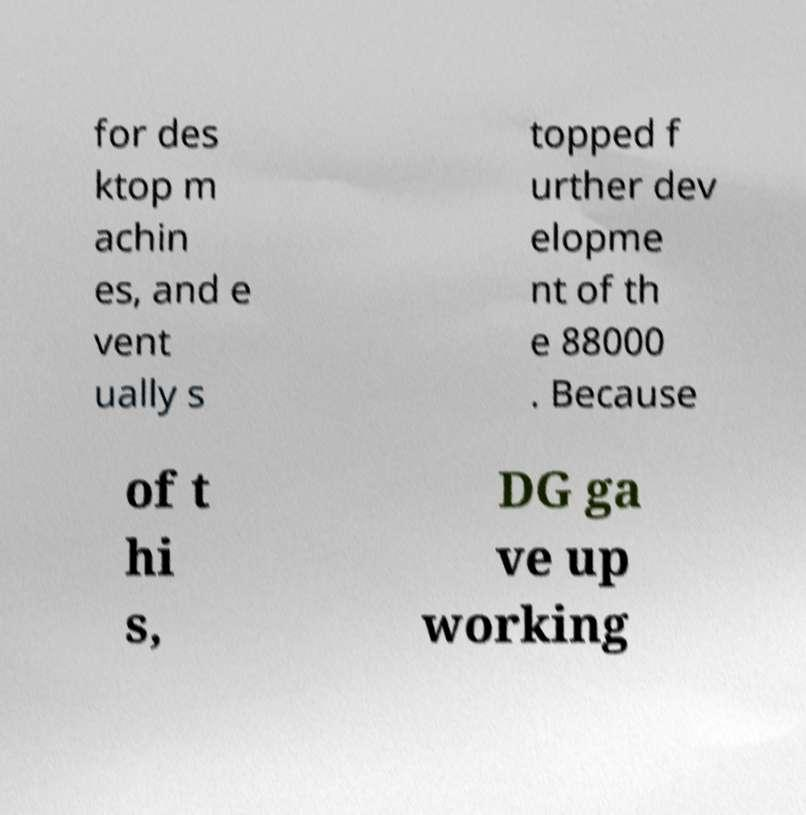I need the written content from this picture converted into text. Can you do that? for des ktop m achin es, and e vent ually s topped f urther dev elopme nt of th e 88000 . Because of t hi s, DG ga ve up working 